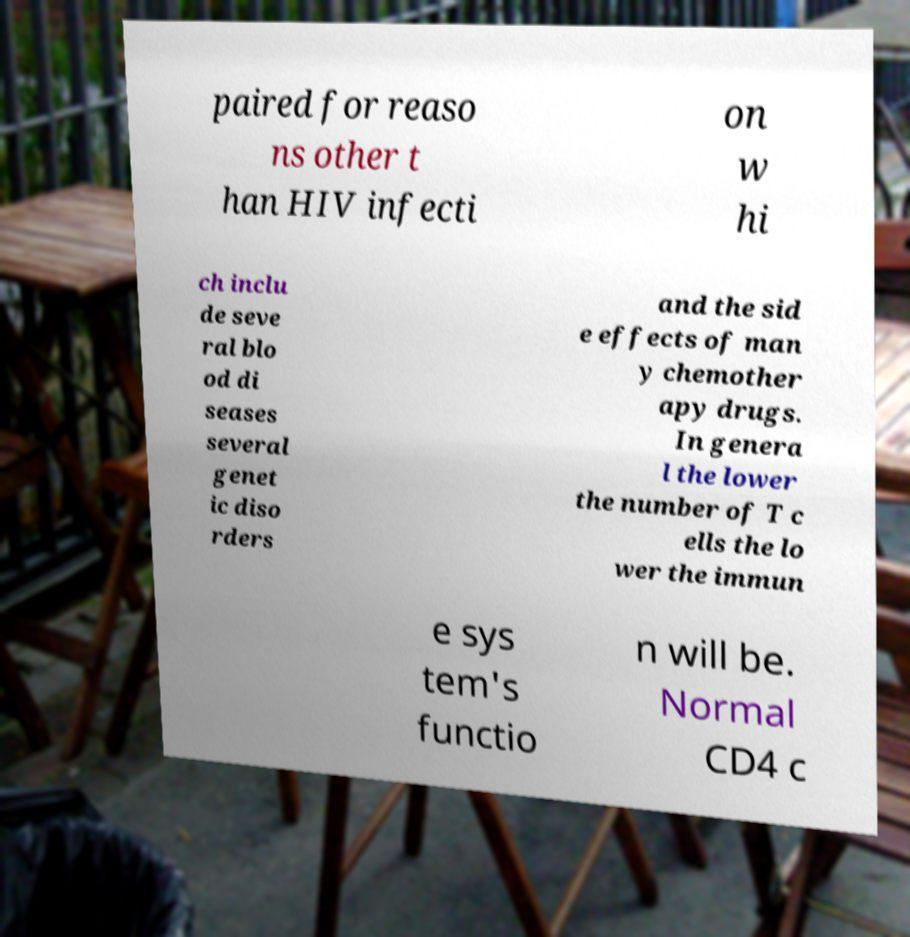Could you assist in decoding the text presented in this image and type it out clearly? paired for reaso ns other t han HIV infecti on w hi ch inclu de seve ral blo od di seases several genet ic diso rders and the sid e effects of man y chemother apy drugs. In genera l the lower the number of T c ells the lo wer the immun e sys tem's functio n will be. Normal CD4 c 